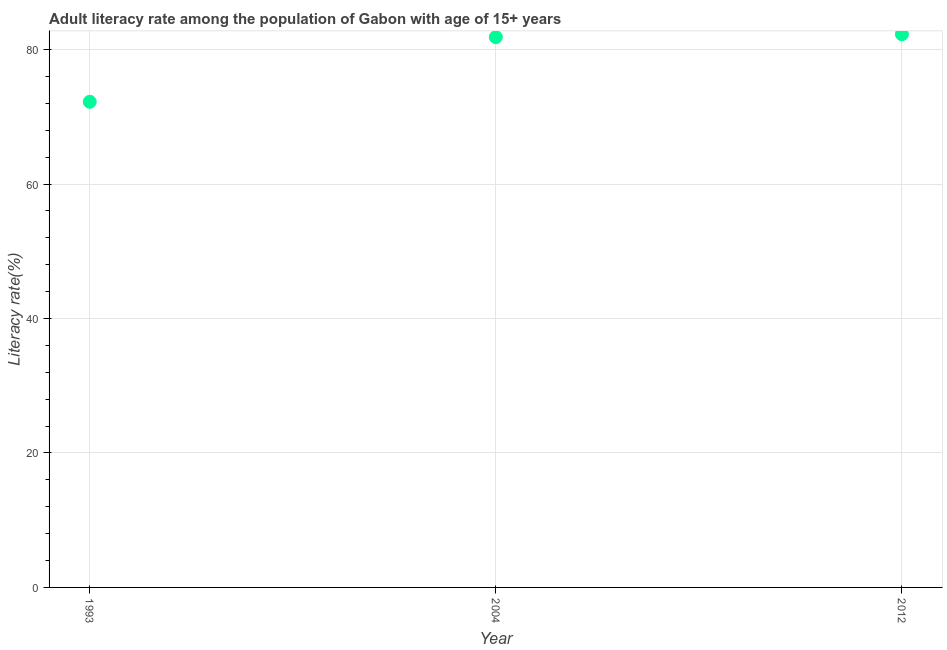What is the adult literacy rate in 2012?
Keep it short and to the point. 82.28. Across all years, what is the maximum adult literacy rate?
Your answer should be compact. 82.28. Across all years, what is the minimum adult literacy rate?
Make the answer very short. 72.23. In which year was the adult literacy rate maximum?
Your answer should be compact. 2012. In which year was the adult literacy rate minimum?
Ensure brevity in your answer.  1993. What is the sum of the adult literacy rate?
Provide a short and direct response. 236.36. What is the difference between the adult literacy rate in 1993 and 2004?
Ensure brevity in your answer.  -9.61. What is the average adult literacy rate per year?
Provide a succinct answer. 78.79. What is the median adult literacy rate?
Offer a very short reply. 81.85. In how many years, is the adult literacy rate greater than 68 %?
Provide a short and direct response. 3. Do a majority of the years between 2012 and 2004 (inclusive) have adult literacy rate greater than 24 %?
Make the answer very short. No. What is the ratio of the adult literacy rate in 2004 to that in 2012?
Offer a very short reply. 0.99. Is the difference between the adult literacy rate in 2004 and 2012 greater than the difference between any two years?
Your answer should be compact. No. What is the difference between the highest and the second highest adult literacy rate?
Your response must be concise. 0.44. Is the sum of the adult literacy rate in 1993 and 2004 greater than the maximum adult literacy rate across all years?
Make the answer very short. Yes. What is the difference between the highest and the lowest adult literacy rate?
Keep it short and to the point. 10.05. In how many years, is the adult literacy rate greater than the average adult literacy rate taken over all years?
Provide a succinct answer. 2. Does the adult literacy rate monotonically increase over the years?
Give a very brief answer. Yes. How many years are there in the graph?
Offer a terse response. 3. Does the graph contain grids?
Offer a very short reply. Yes. What is the title of the graph?
Your answer should be compact. Adult literacy rate among the population of Gabon with age of 15+ years. What is the label or title of the X-axis?
Your response must be concise. Year. What is the label or title of the Y-axis?
Keep it short and to the point. Literacy rate(%). What is the Literacy rate(%) in 1993?
Make the answer very short. 72.23. What is the Literacy rate(%) in 2004?
Your response must be concise. 81.85. What is the Literacy rate(%) in 2012?
Make the answer very short. 82.28. What is the difference between the Literacy rate(%) in 1993 and 2004?
Your answer should be compact. -9.61. What is the difference between the Literacy rate(%) in 1993 and 2012?
Provide a succinct answer. -10.05. What is the difference between the Literacy rate(%) in 2004 and 2012?
Ensure brevity in your answer.  -0.44. What is the ratio of the Literacy rate(%) in 1993 to that in 2004?
Give a very brief answer. 0.88. What is the ratio of the Literacy rate(%) in 1993 to that in 2012?
Your response must be concise. 0.88. 